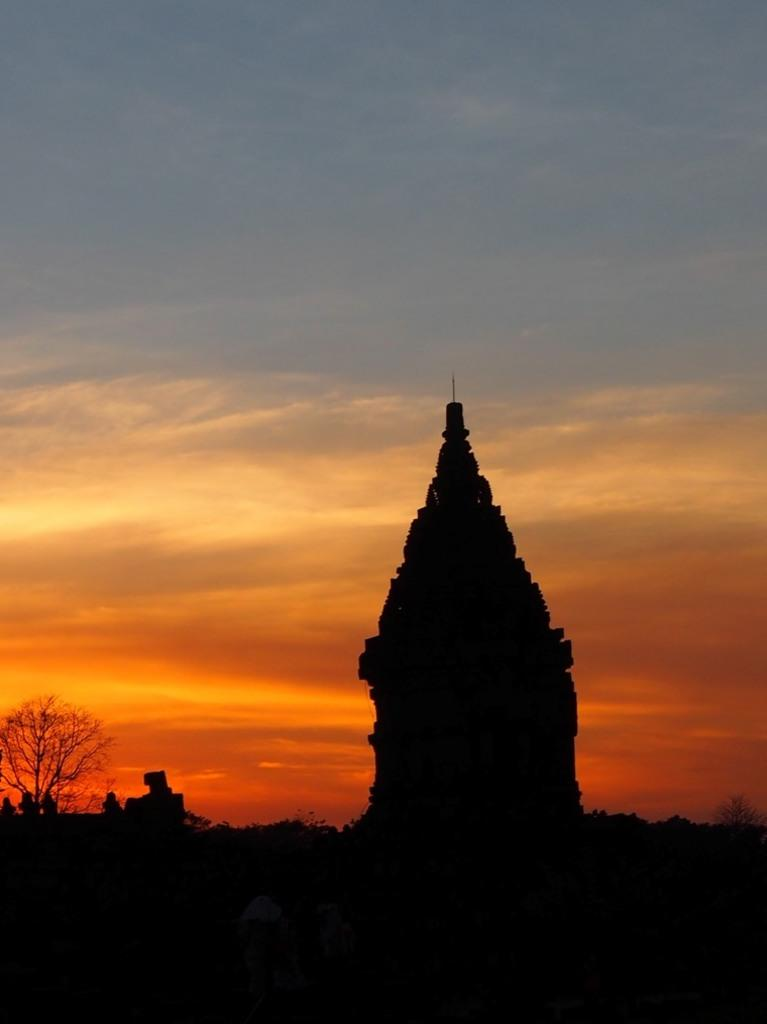What is the tall, pointed structure in the image? There is a spire in the image. What type of plant can be seen in the image? There is a tree in the image. What time of day does the image appear to depict? The image appears to depict a sunset. What part of the tree is used for balancing on the yoke in the image? There is no yoke or balancing activity present in the image; it features a spire and a tree during a sunset. 